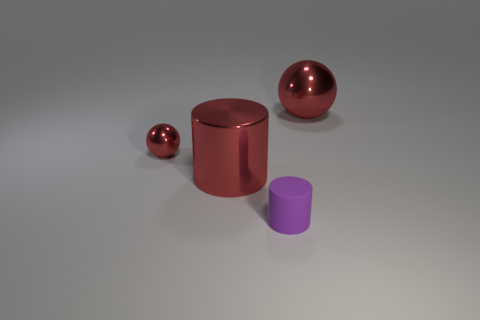Is there a brown rubber ball of the same size as the purple matte cylinder?
Give a very brief answer. No. The purple rubber cylinder has what size?
Offer a terse response. Small. What number of red cylinders are the same size as the rubber thing?
Make the answer very short. 0. Is the number of tiny red shiny things that are right of the small purple cylinder less than the number of metal things that are left of the big red ball?
Offer a very short reply. Yes. There is a metallic thing that is on the left side of the large metallic object in front of the ball in front of the large metal sphere; how big is it?
Provide a succinct answer. Small. There is a red thing that is behind the big shiny cylinder and on the left side of the matte thing; what size is it?
Your response must be concise. Small. What shape is the large shiny object behind the sphere to the left of the large red metal ball?
Provide a short and direct response. Sphere. Are there any other things that are the same color as the small matte thing?
Provide a succinct answer. No. There is a metal thing right of the red cylinder; what shape is it?
Provide a succinct answer. Sphere. There is a thing that is right of the shiny cylinder and in front of the big ball; what shape is it?
Your answer should be compact. Cylinder. 